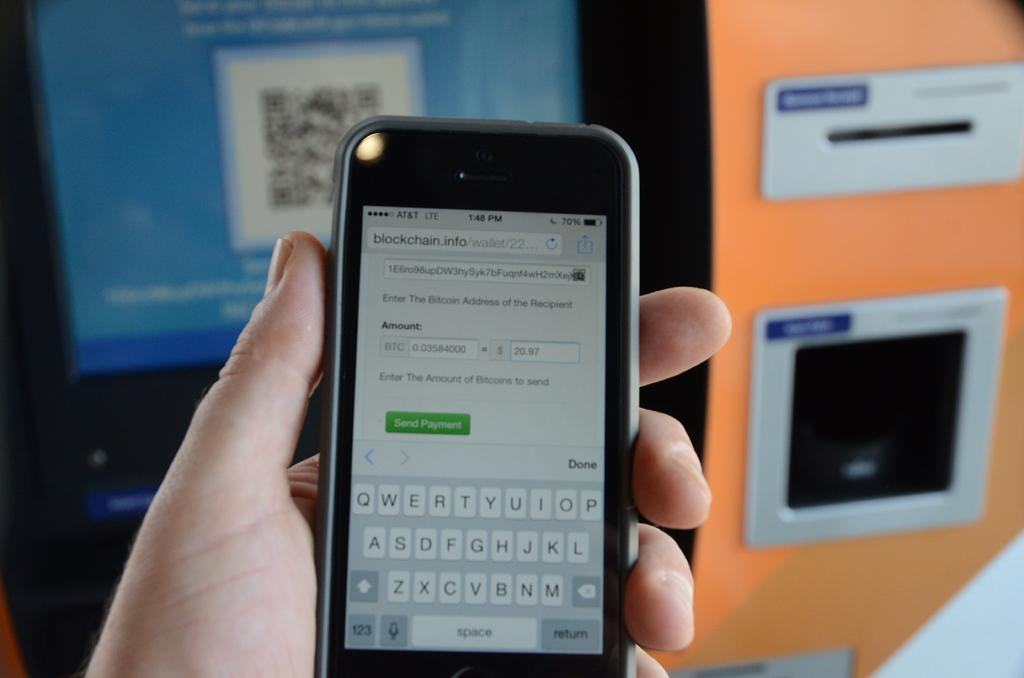What device is being held by the person in the image? There is a smartphone in the picture, and a person is holding it. What can be inferred about the person's activity based on the image? The person is likely using the smartphone, as they are holding it. What color is the object visible in the background? The object in the background is orange-colored. What feature does the orange-colored object have? The orange-colored object has a slot. What type of thing is your aunt holding in the image? There is no mention of an aunt or any person other than the one holding the smartphone in the image. The smartphone is the only device being held. 